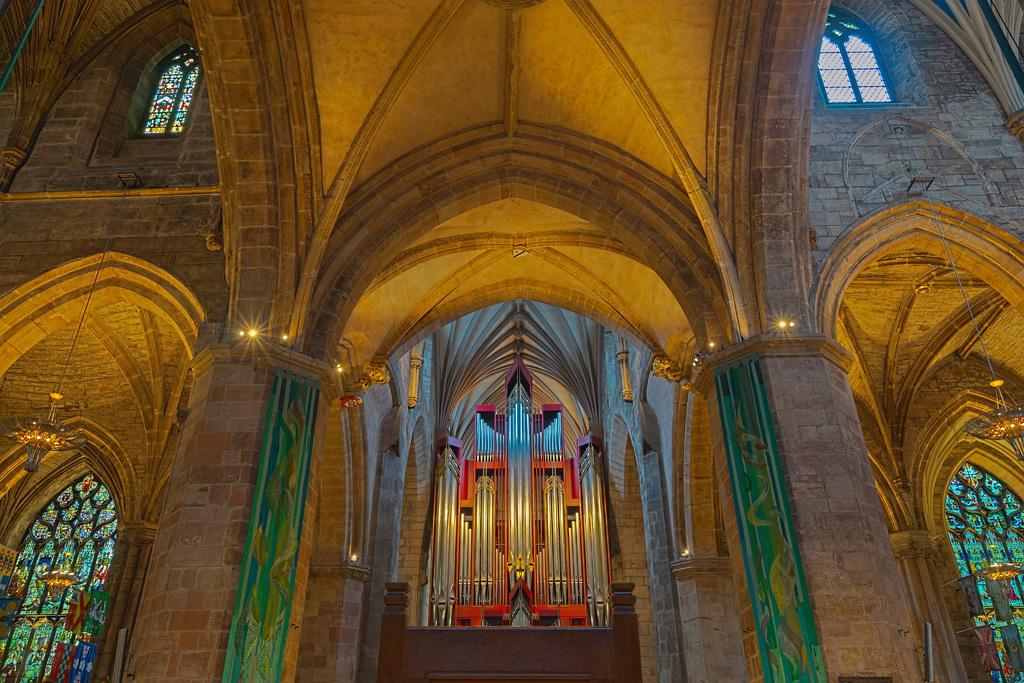Can you describe this image briefly? This is inside view of a building. we can see windows, designs on the window glasses, lights hanging in the air, lights on the walls and in the middle there are objects on a platform. 